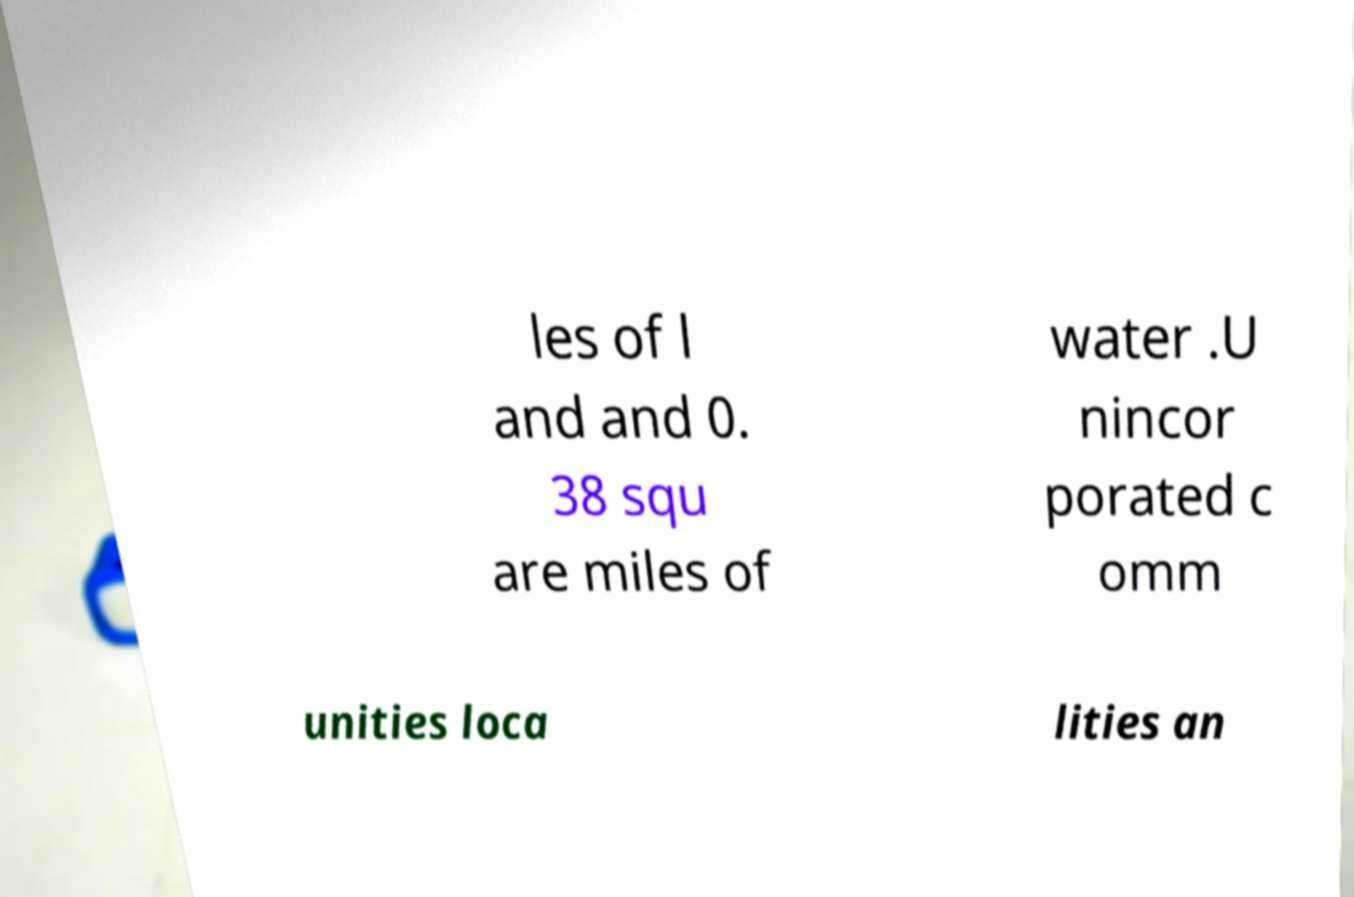Can you read and provide the text displayed in the image?This photo seems to have some interesting text. Can you extract and type it out for me? les of l and and 0. 38 squ are miles of water .U nincor porated c omm unities loca lities an 